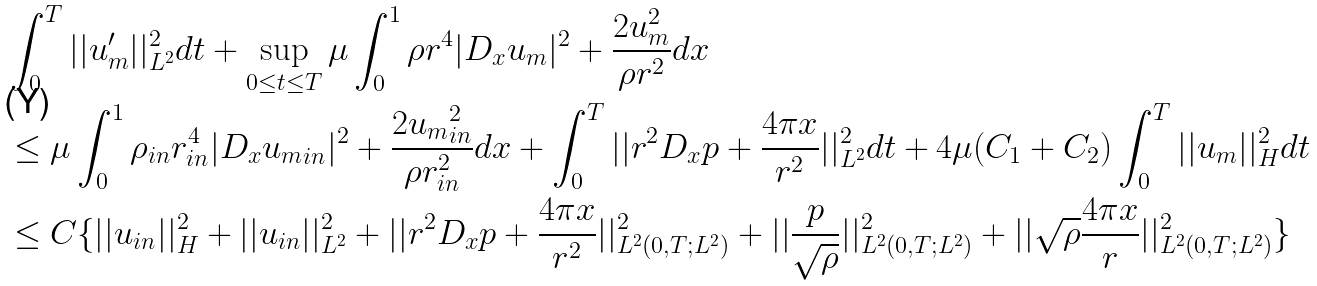Convert formula to latex. <formula><loc_0><loc_0><loc_500><loc_500>& \int _ { 0 } ^ { T } | | u _ { m } ^ { \prime } | | ^ { 2 } _ { L ^ { 2 } } d t + \sup _ { 0 \leq t \leq T } \mu \int _ { 0 } ^ { 1 } \rho r ^ { 4 } | D _ { x } u _ { m } | ^ { 2 } + \frac { 2 u _ { m } ^ { 2 } } { \rho r ^ { 2 } } d x \\ & \leq \mu \int _ { 0 } ^ { 1 } \rho _ { i n } r _ { i n } ^ { 4 } | D _ { x } { u _ { m } } _ { i n } | ^ { 2 } + \frac { 2 { u _ { m } } _ { i n } ^ { 2 } } { \rho r _ { i n } ^ { 2 } } d x + \int _ { 0 } ^ { T } | | r ^ { 2 } D _ { x } p + \frac { 4 \pi x } { r ^ { 2 } } | | _ { L ^ { 2 } } ^ { 2 } d t + 4 \mu ( C _ { 1 } + C _ { 2 } ) \int _ { 0 } ^ { T } | | u _ { m } | | _ { H } ^ { 2 } d t \\ & \leq C \{ | | u _ { i n } | | _ { H } ^ { 2 } + | | u _ { i n } | | _ { L ^ { 2 } } ^ { 2 } + | | r ^ { 2 } D _ { x } p + \frac { 4 \pi x } { r ^ { 2 } } | | ^ { 2 } _ { L ^ { 2 } ( 0 , T ; L ^ { 2 } ) } + | | \frac { p } { \sqrt { \rho } } | | ^ { 2 } _ { L ^ { 2 } ( 0 , T ; L ^ { 2 } ) } + | | \sqrt { \rho } \frac { 4 \pi x } { r } | | ^ { 2 } _ { L ^ { 2 } ( 0 , T ; L ^ { 2 } ) } \}</formula> 